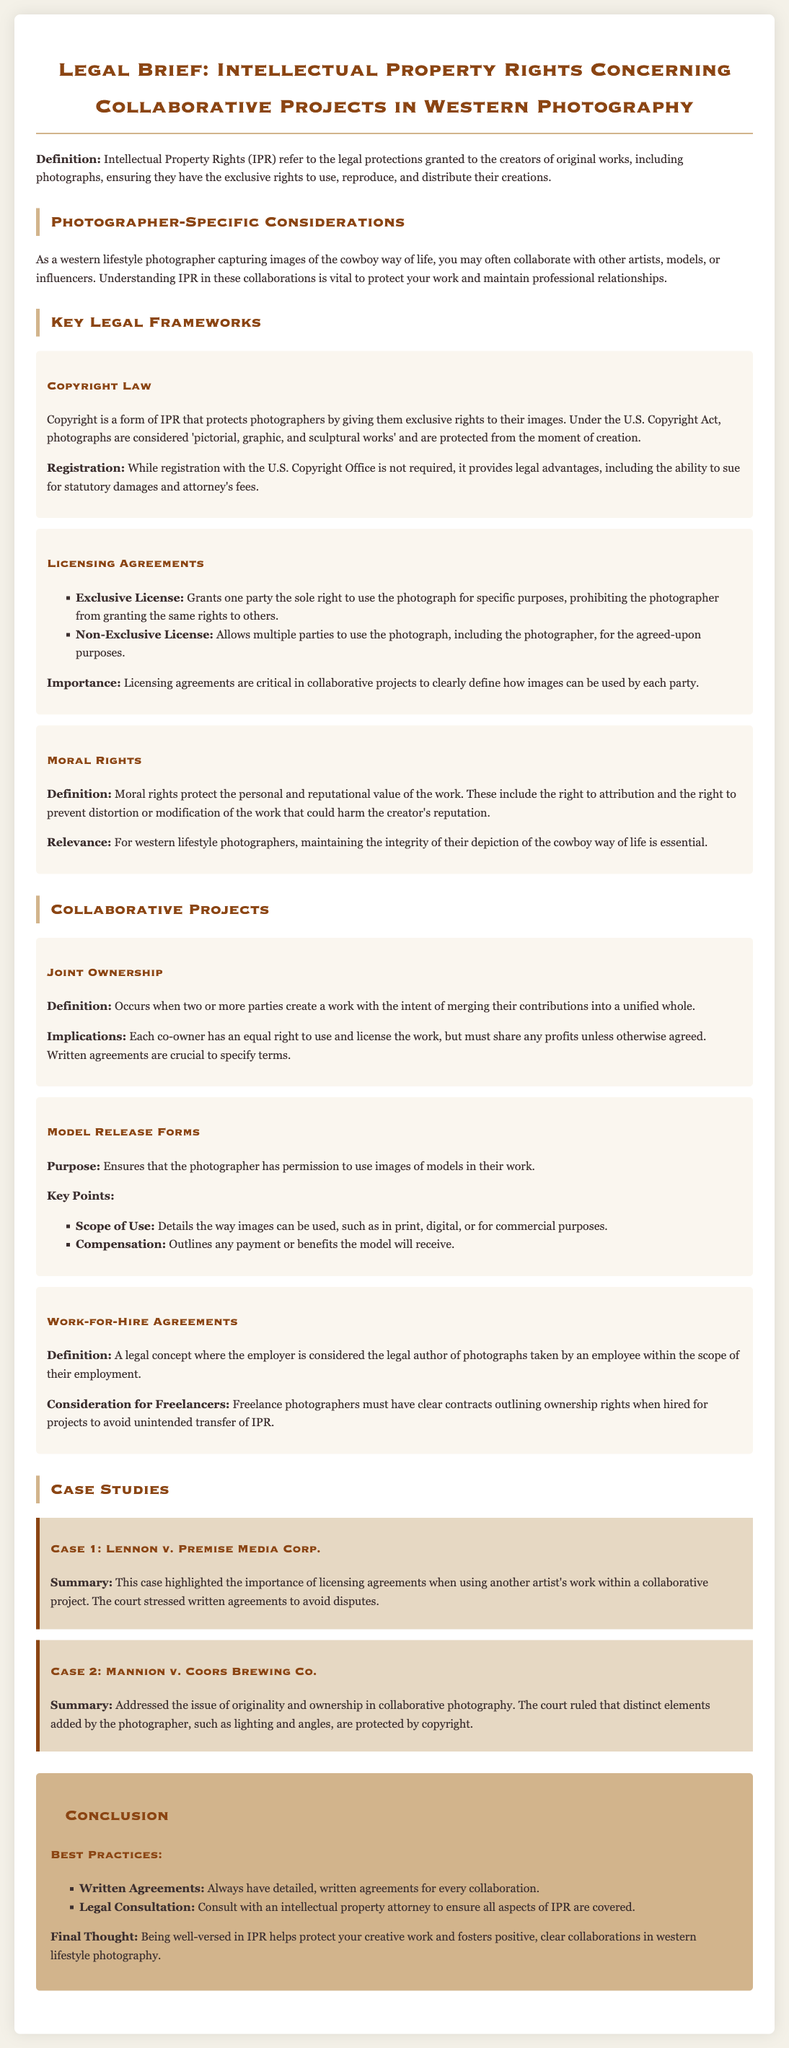what are Intellectual Property Rights? Intellectual Property Rights refer to the legal protections granted to the creators of original works, including photographs, ensuring they have the exclusive rights to use, reproduce, and distribute their creations.
Answer: legal protections what is a key legal framework for photographers? Copyright is a form of IPR that protects photographers by giving them exclusive rights to their images.
Answer: Copyright Law what must be outlined in Model Release Forms? Model Release Forms must outline the scope of use and compensation for the model.
Answer: scope of use and compensation what are the implications of Joint Ownership? Each co-owner has an equal right to use and license the work, but must share any profits unless otherwise agreed.
Answer: equal right to use and share profits how many case studies are presented? There are two case studies presented in the document.
Answer: two what should collaborative projects always include? Collaborative projects should always include detailed, written agreements.
Answer: detailed, written agreements what does the term Work-for-Hire Agreements refer to? Work-for-Hire Agreements refer to a legal concept where the employer is considered the legal author of photographs taken by an employee within the scope of their employment.
Answer: legal author of photographs what is the purpose of Licensing Agreements? Licensing Agreements are critical in collaborative projects to clearly define how images can be used by each party.
Answer: clearly define image usage who should you consult for legal aspects of IPR? You should consult with an intellectual property attorney to ensure all aspects of IPR are covered.
Answer: intellectual property attorney 